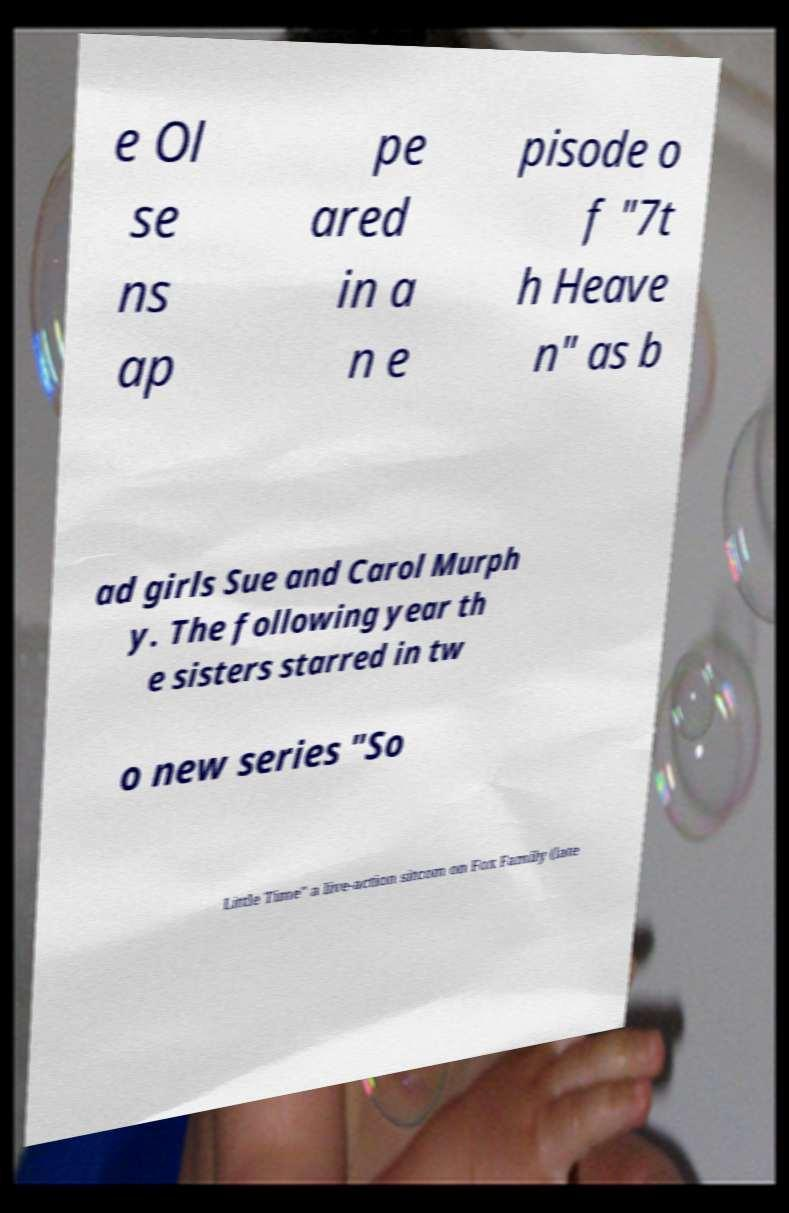I need the written content from this picture converted into text. Can you do that? e Ol se ns ap pe ared in a n e pisode o f "7t h Heave n" as b ad girls Sue and Carol Murph y. The following year th e sisters starred in tw o new series "So Little Time" a live-action sitcom on Fox Family (late 